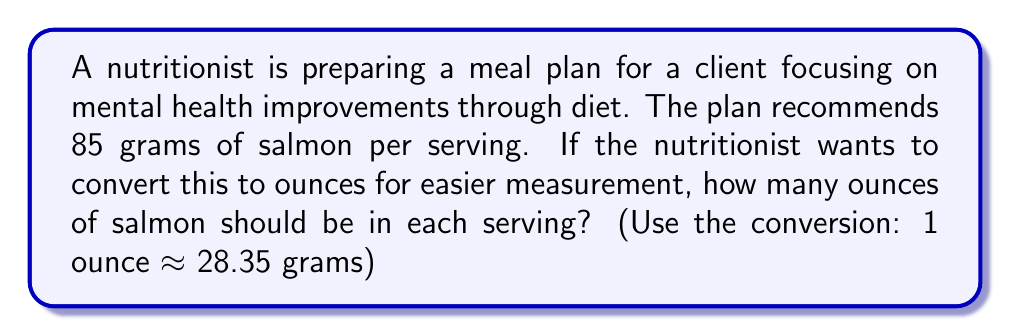Help me with this question. To convert grams to ounces, we need to divide the given weight in grams by the conversion factor.

Given:
- Recommended serving of salmon: 85 grams
- Conversion factor: 1 ounce ≈ 28.35 grams

Let's set up the conversion:

$$ \text{Ounces of salmon} = \frac{\text{Grams of salmon}}{\text{Grams per ounce}} $$

Substituting the values:

$$ \text{Ounces of salmon} = \frac{85 \text{ grams}}{28.35 \text{ grams/ounce}} $$

Performing the division:

$$ \text{Ounces of salmon} = 2.9982 \text{ ounces} $$

Rounding to the nearest tenth of an ounce for practical measurement:

$$ \text{Ounces of salmon} ≈ 3.0 \text{ ounces} $$
Answer: 3.0 ounces 